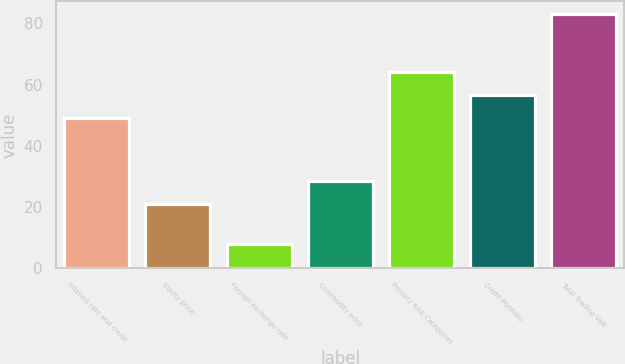Convert chart to OTSL. <chart><loc_0><loc_0><loc_500><loc_500><bar_chart><fcel>Interest rate and credit<fcel>Equity price<fcel>Foreign exchange rate<fcel>Commodity price<fcel>Primary Risk Categories<fcel>Credit Portfolio<fcel>Total Trading VaR<nl><fcel>49<fcel>21<fcel>8<fcel>28.5<fcel>64<fcel>56.5<fcel>83<nl></chart> 